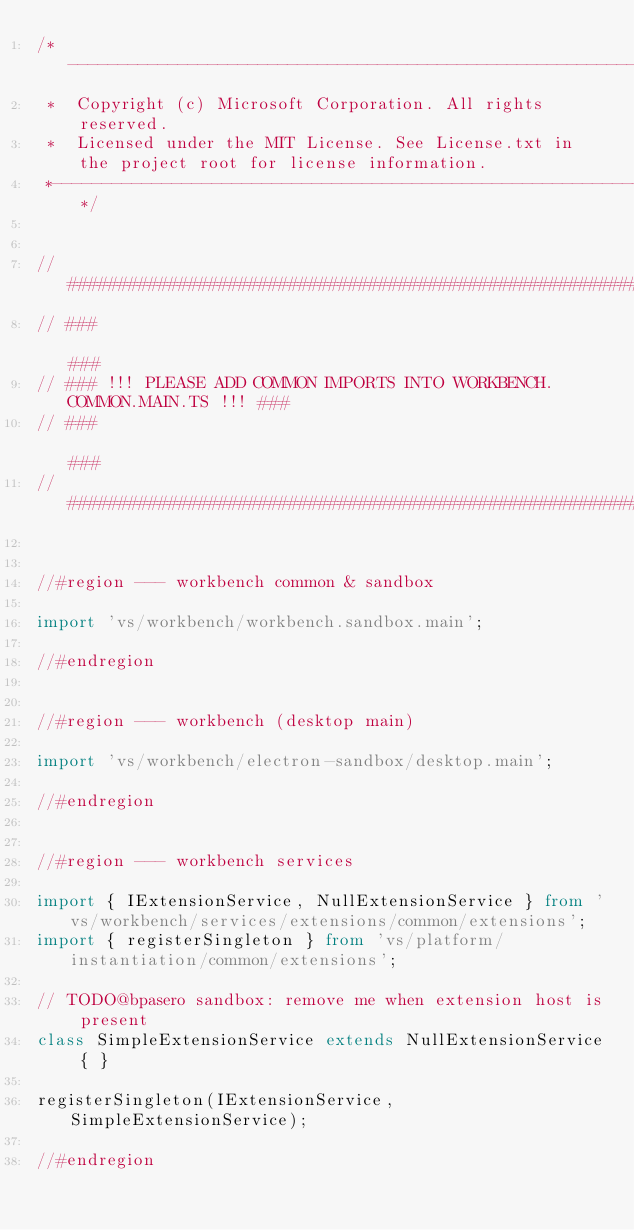<code> <loc_0><loc_0><loc_500><loc_500><_TypeScript_>/*---------------------------------------------------------------------------------------------
 *  Copyright (c) Microsoft Corporation. All rights reserved.
 *  Licensed under the MIT License. See License.txt in the project root for license information.
 *--------------------------------------------------------------------------------------------*/


// #######################################################################
// ###                                                                 ###
// ### !!! PLEASE ADD COMMON IMPORTS INTO WORKBENCH.COMMON.MAIN.TS !!! ###
// ###                                                                 ###
// #######################################################################


//#region --- workbench common & sandbox

import 'vs/workbench/workbench.sandbox.main';

//#endregion


//#region --- workbench (desktop main)

import 'vs/workbench/electron-sandbox/desktop.main';

//#endregion


//#region --- workbench services

import { IExtensionService, NullExtensionService } from 'vs/workbench/services/extensions/common/extensions';
import { registerSingleton } from 'vs/platform/instantiation/common/extensions';

// TODO@bpasero sandbox: remove me when extension host is present
class SimpleExtensionService extends NullExtensionService { }

registerSingleton(IExtensionService, SimpleExtensionService);

//#endregion
</code> 